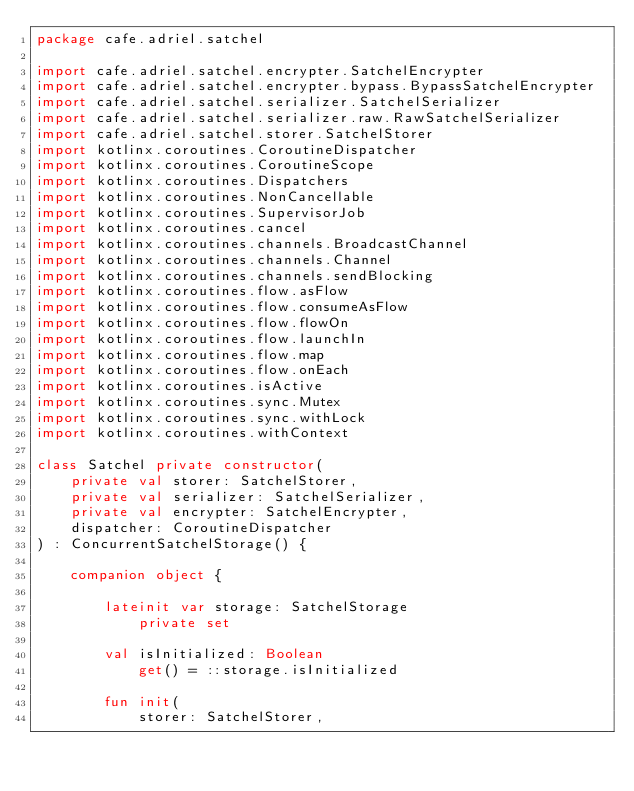Convert code to text. <code><loc_0><loc_0><loc_500><loc_500><_Kotlin_>package cafe.adriel.satchel

import cafe.adriel.satchel.encrypter.SatchelEncrypter
import cafe.adriel.satchel.encrypter.bypass.BypassSatchelEncrypter
import cafe.adriel.satchel.serializer.SatchelSerializer
import cafe.adriel.satchel.serializer.raw.RawSatchelSerializer
import cafe.adriel.satchel.storer.SatchelStorer
import kotlinx.coroutines.CoroutineDispatcher
import kotlinx.coroutines.CoroutineScope
import kotlinx.coroutines.Dispatchers
import kotlinx.coroutines.NonCancellable
import kotlinx.coroutines.SupervisorJob
import kotlinx.coroutines.cancel
import kotlinx.coroutines.channels.BroadcastChannel
import kotlinx.coroutines.channels.Channel
import kotlinx.coroutines.channels.sendBlocking
import kotlinx.coroutines.flow.asFlow
import kotlinx.coroutines.flow.consumeAsFlow
import kotlinx.coroutines.flow.flowOn
import kotlinx.coroutines.flow.launchIn
import kotlinx.coroutines.flow.map
import kotlinx.coroutines.flow.onEach
import kotlinx.coroutines.isActive
import kotlinx.coroutines.sync.Mutex
import kotlinx.coroutines.sync.withLock
import kotlinx.coroutines.withContext

class Satchel private constructor(
    private val storer: SatchelStorer,
    private val serializer: SatchelSerializer,
    private val encrypter: SatchelEncrypter,
    dispatcher: CoroutineDispatcher
) : ConcurrentSatchelStorage() {

    companion object {

        lateinit var storage: SatchelStorage
            private set

        val isInitialized: Boolean
            get() = ::storage.isInitialized

        fun init(
            storer: SatchelStorer,</code> 